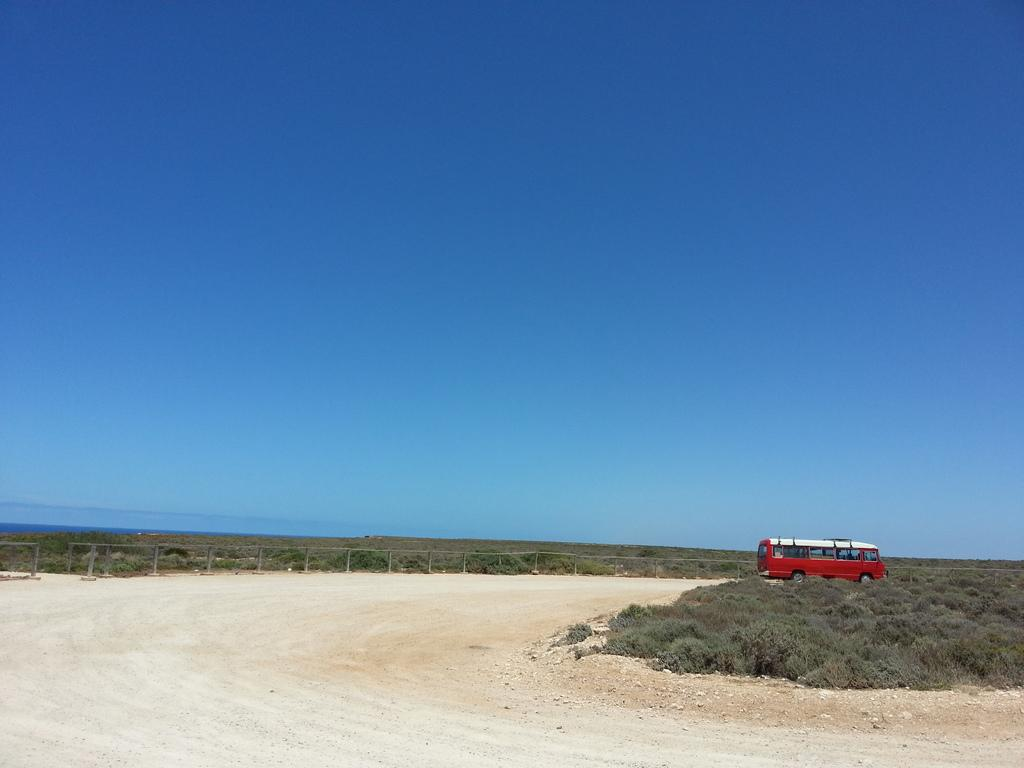What can be seen in the foreground of the picture? In the foreground of the picture, there are plants, stones, a path, and a vehicle. What else is present in the foreground of the picture? Besides the mentioned elements, there are also plants in the middle of the picture and fencing in the middle of the picture. What is visible at the top of the picture? The sky is visible at the top of the picture. What type of waves can be seen crashing against the rocks in the picture? There are no waves or rocks present in the image; it features plants, stones, a path, a vehicle, and fencing. How far does the range of the fencing extend in the picture? The range of the fencing cannot be determined from the image, as it only shows a portion of the fencing. 